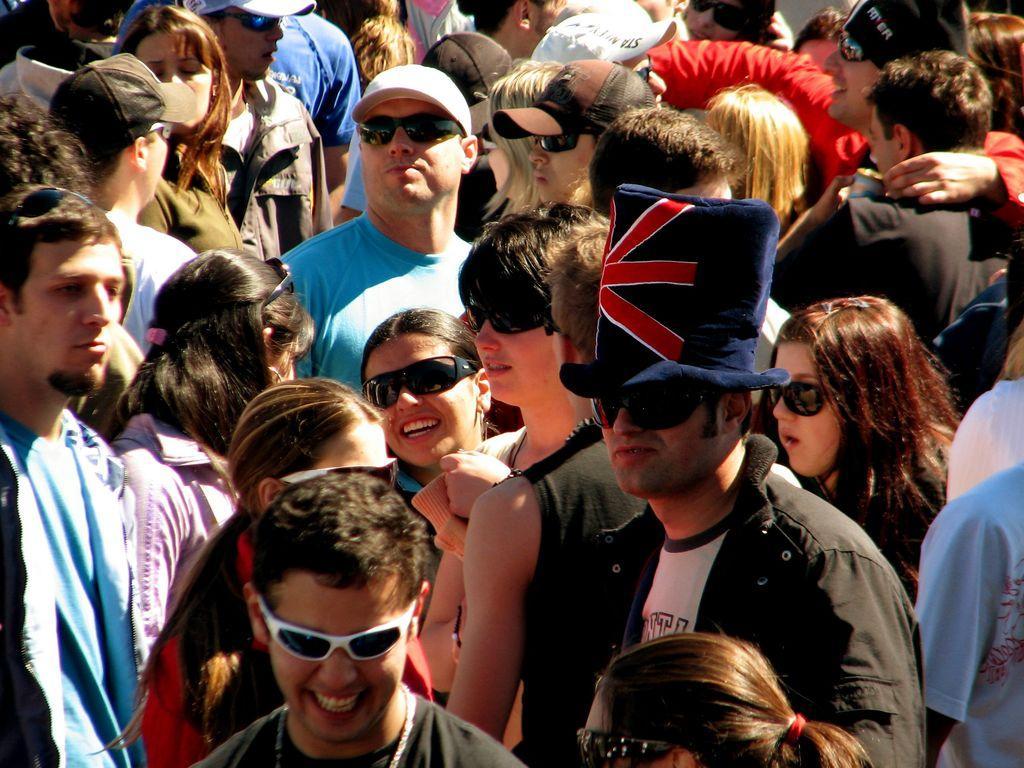How would you summarize this image in a sentence or two? This picture seems to be clicked outside. In this picture we can see the group of people standing on the ground. 